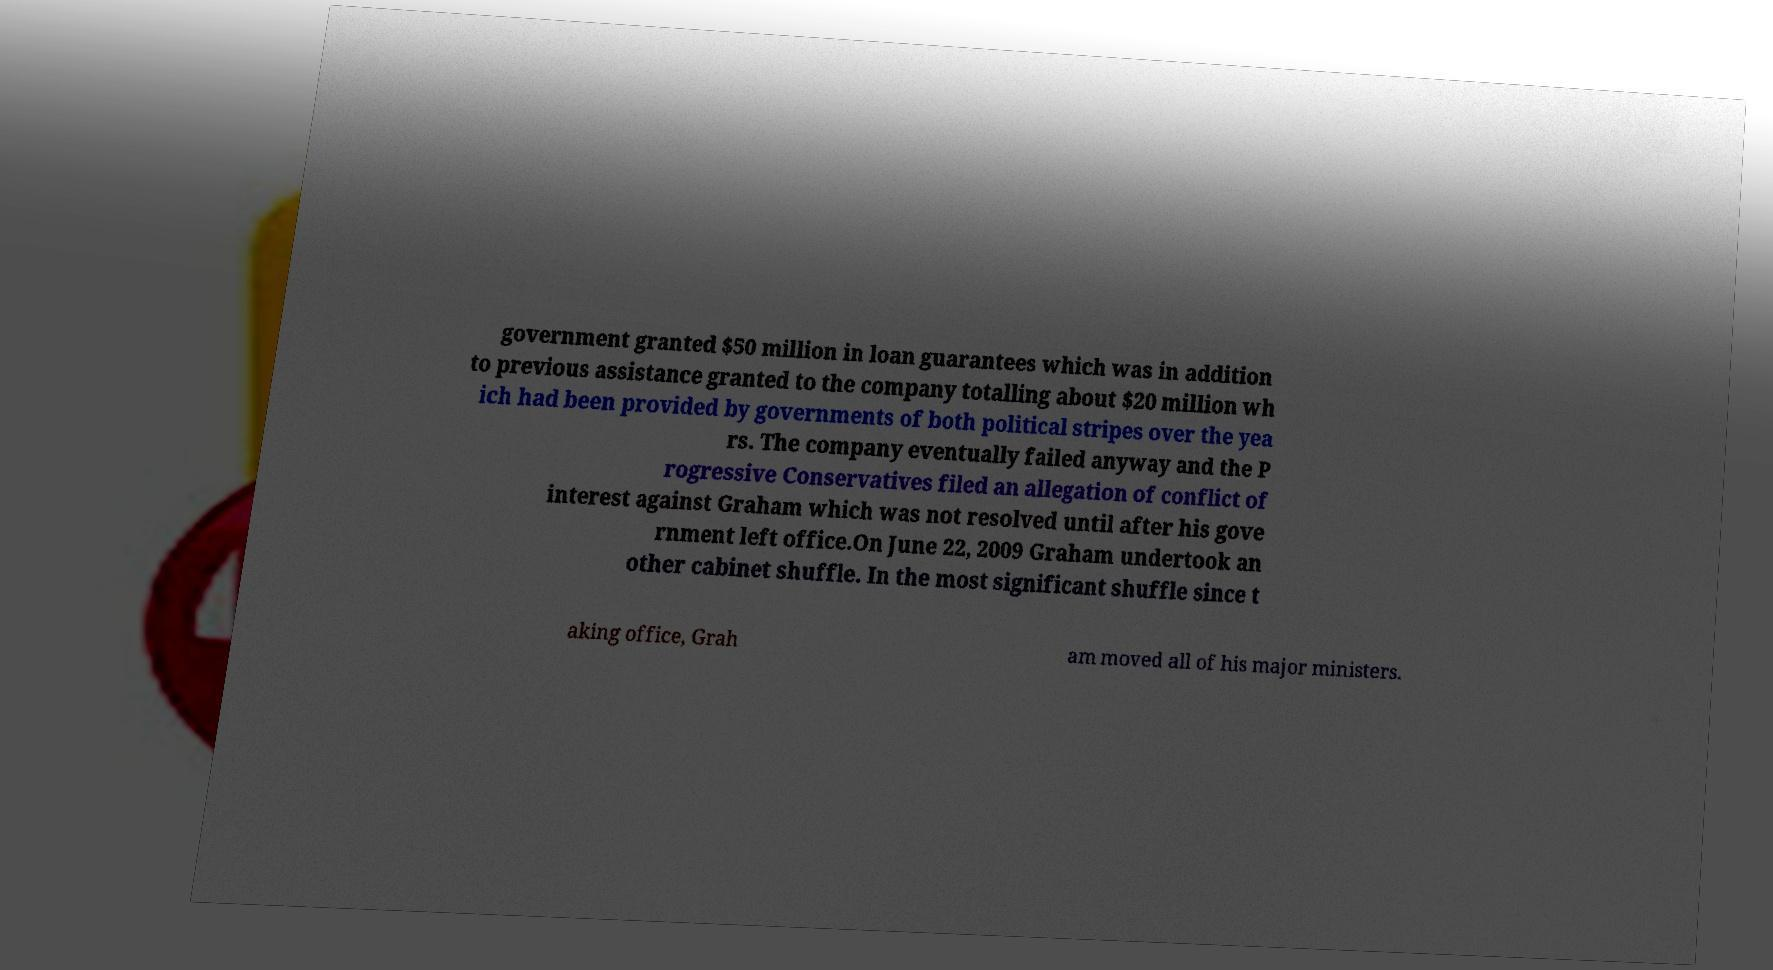Please identify and transcribe the text found in this image. government granted $50 million in loan guarantees which was in addition to previous assistance granted to the company totalling about $20 million wh ich had been provided by governments of both political stripes over the yea rs. The company eventually failed anyway and the P rogressive Conservatives filed an allegation of conflict of interest against Graham which was not resolved until after his gove rnment left office.On June 22, 2009 Graham undertook an other cabinet shuffle. In the most significant shuffle since t aking office, Grah am moved all of his major ministers. 